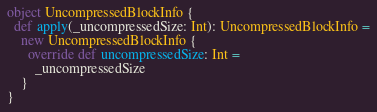<code> <loc_0><loc_0><loc_500><loc_500><_Scala_>object UncompressedBlockInfo {
  def apply(_uncompressedSize: Int): UncompressedBlockInfo =
    new UncompressedBlockInfo {
      override def uncompressedSize: Int =
        _uncompressedSize
    }
}
</code> 